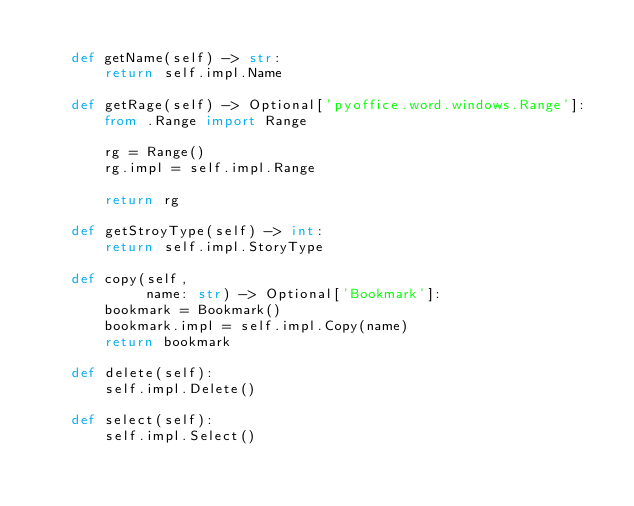Convert code to text. <code><loc_0><loc_0><loc_500><loc_500><_Python_>
    def getName(self) -> str:
        return self.impl.Name

    def getRage(self) -> Optional['pyoffice.word.windows.Range']:
        from .Range import Range

        rg = Range()
        rg.impl = self.impl.Range

        return rg

    def getStroyType(self) -> int:
        return self.impl.StoryType

    def copy(self,
             name: str) -> Optional['Bookmark']:
        bookmark = Bookmark()
        bookmark.impl = self.impl.Copy(name)
        return bookmark

    def delete(self):
        self.impl.Delete()

    def select(self):
        self.impl.Select()
</code> 